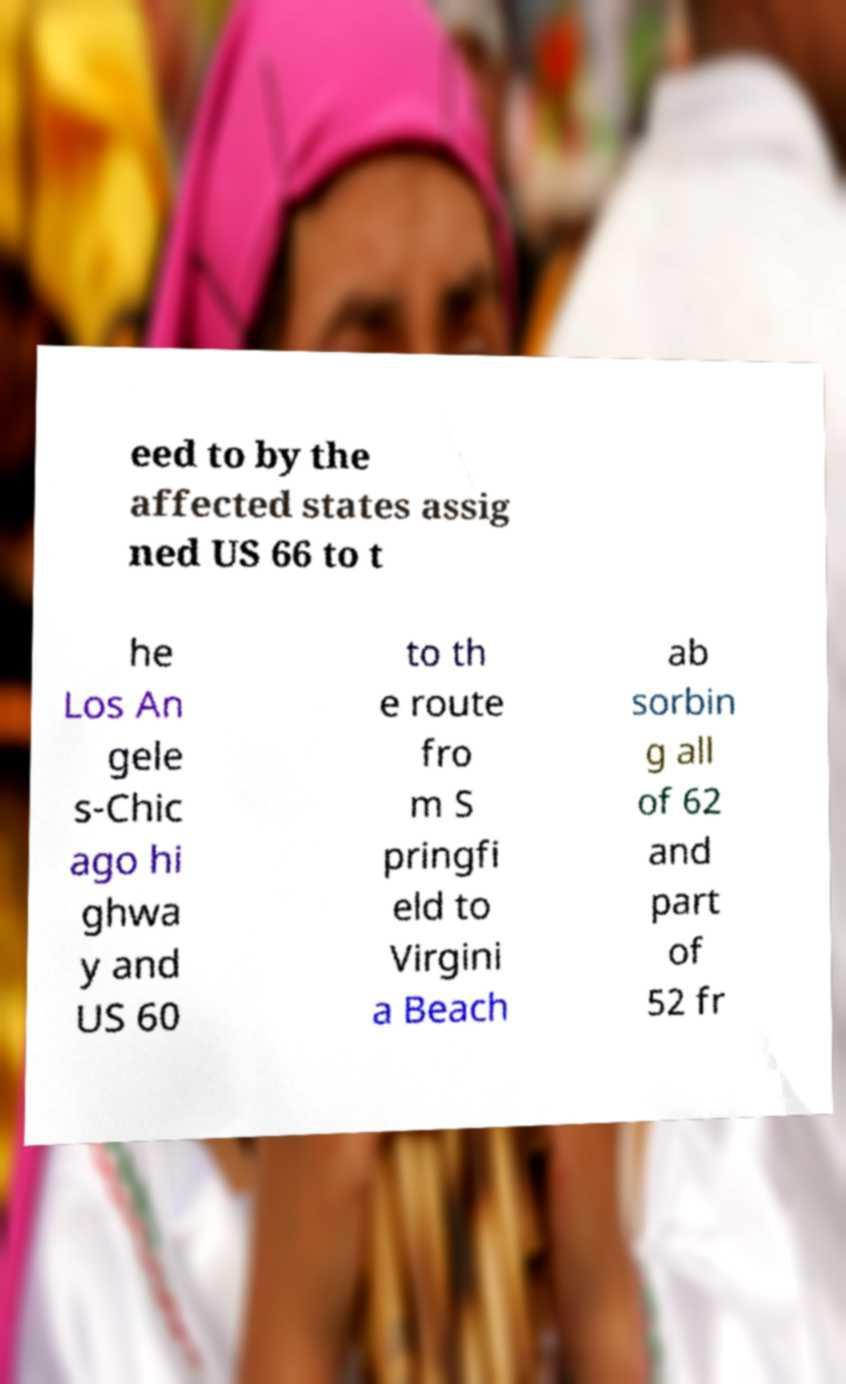I need the written content from this picture converted into text. Can you do that? eed to by the affected states assig ned US 66 to t he Los An gele s-Chic ago hi ghwa y and US 60 to th e route fro m S pringfi eld to Virgini a Beach ab sorbin g all of 62 and part of 52 fr 